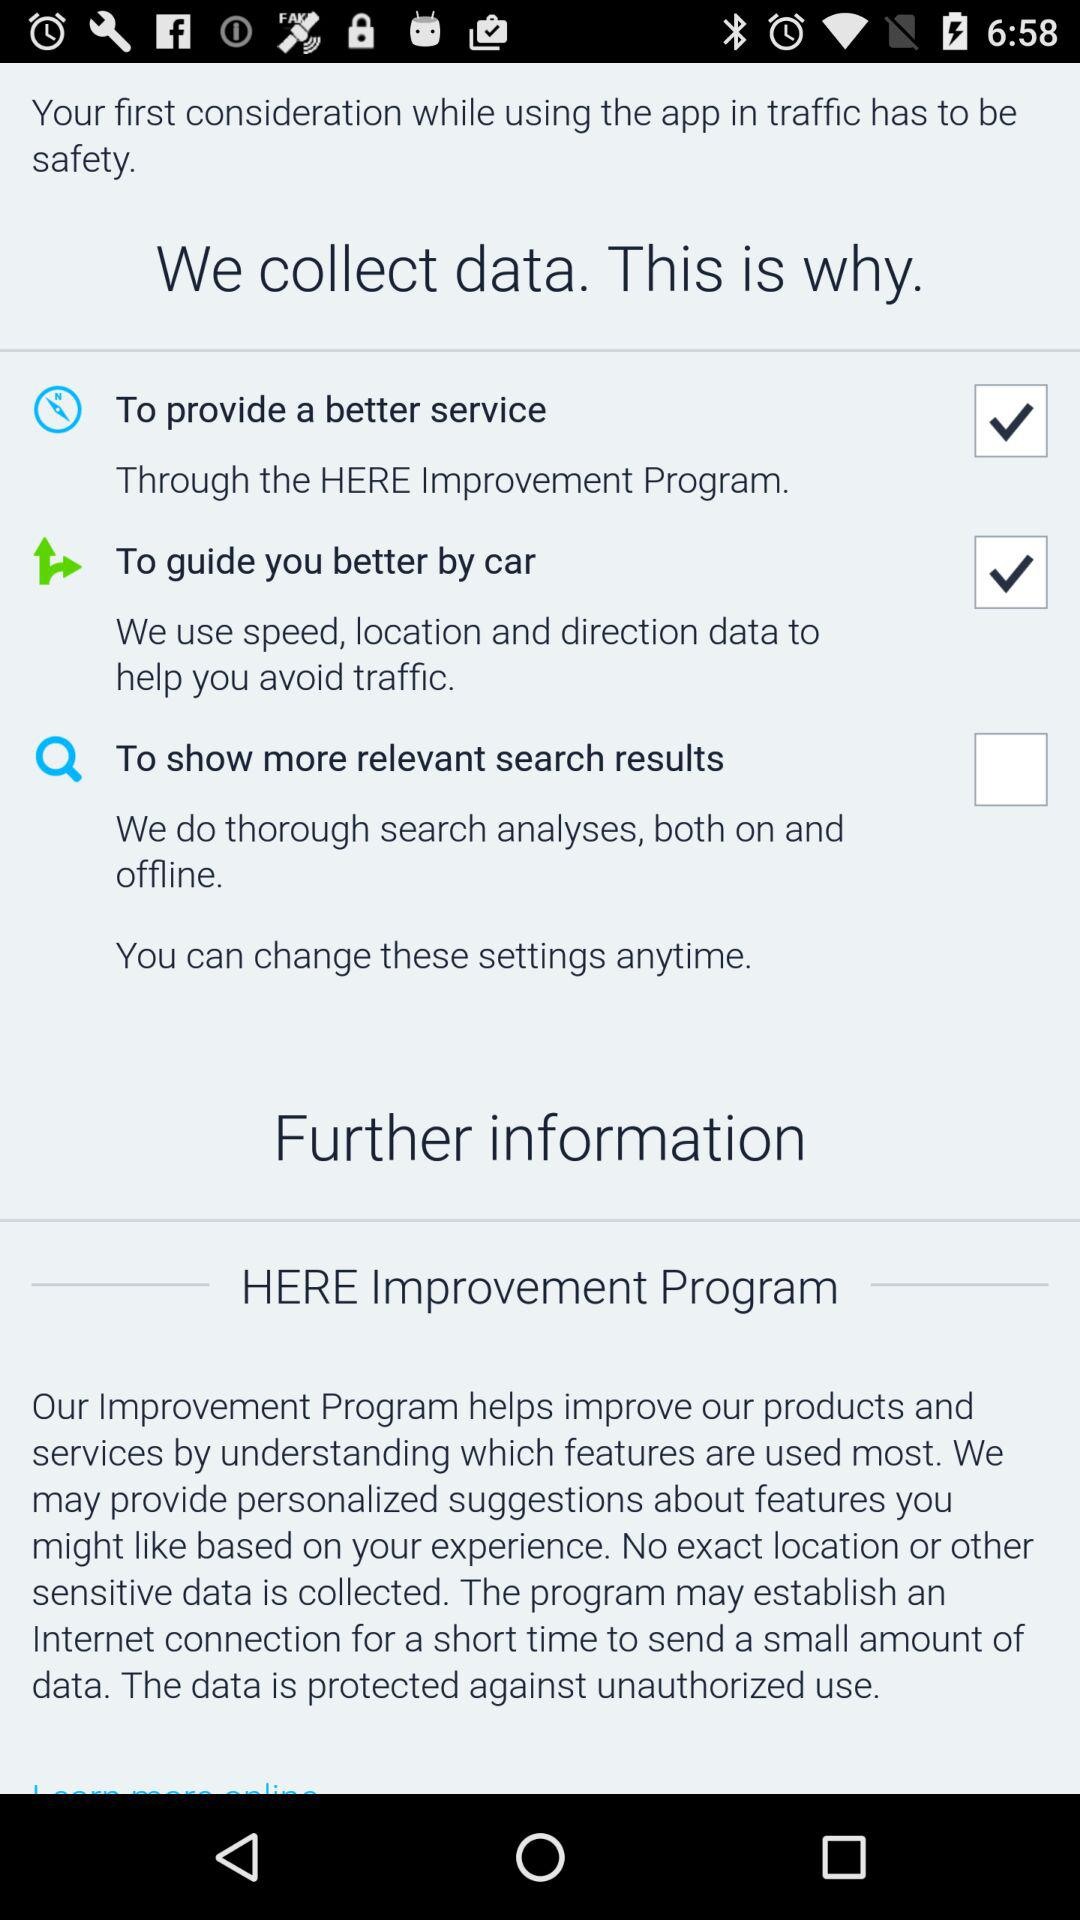How many data collection reasons are there?
Answer the question using a single word or phrase. 3 